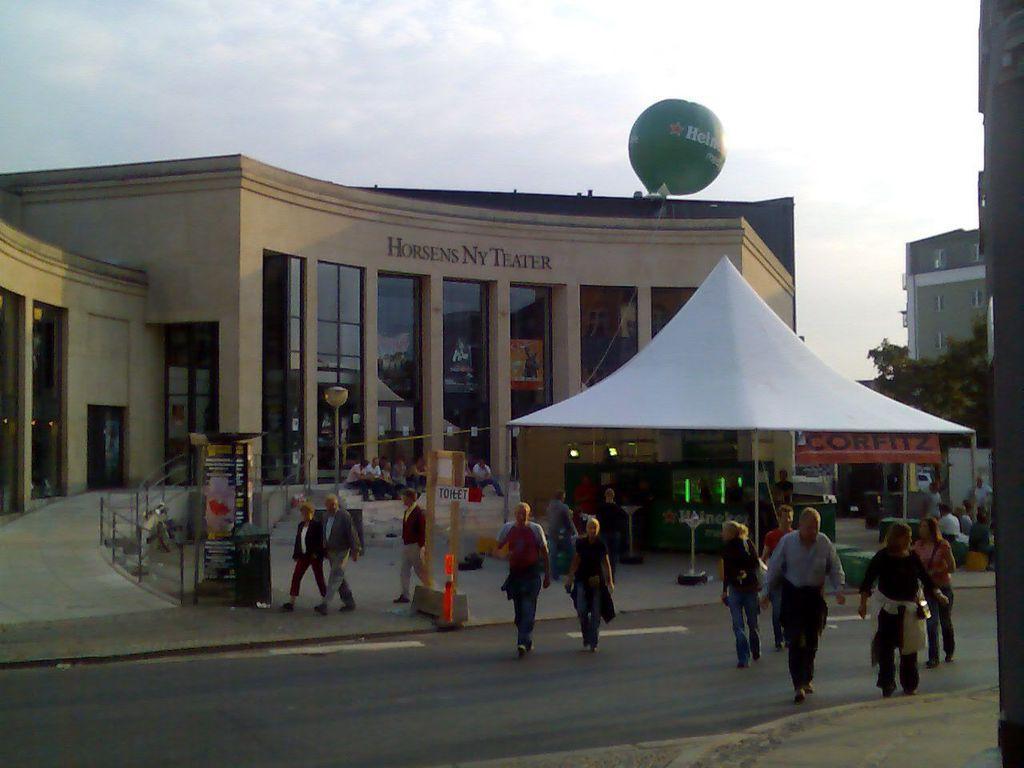Can you describe this image briefly? There are few persons walking and there is a building behind them and there is a tree and a building in the right corner. 